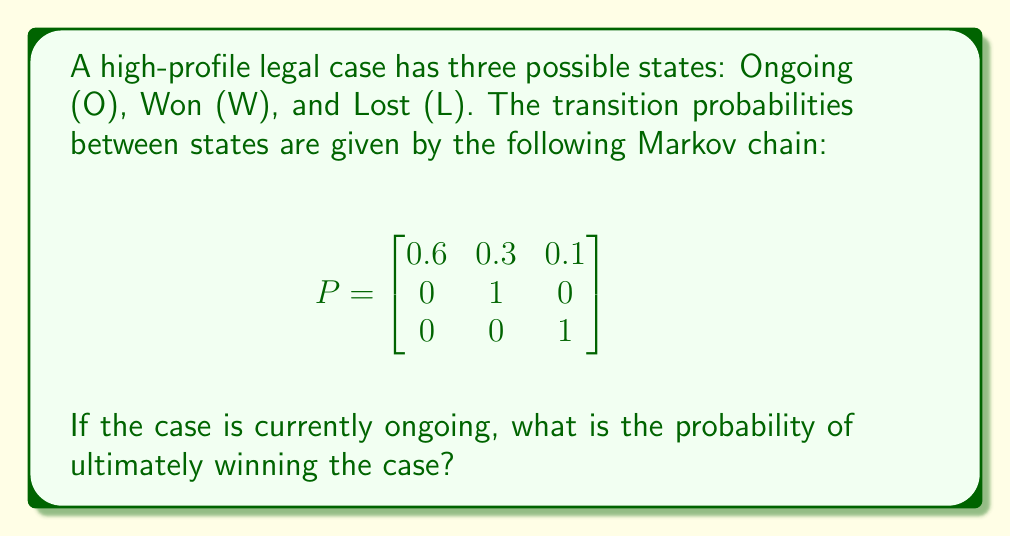Help me with this question. To solve this problem, we need to use the concept of absorbing Markov chains:

1) First, observe that W and L are absorbing states (once reached, the process stays there with probability 1).

2) We need to find the probability of reaching W before L, starting from O.

3) Let $q$ be the probability of eventually winning, starting from O. We can write:

   $q = 0.3 + 0.6q$

   This equation states that we can win immediately with probability 0.3, or stay in O with probability 0.6 and then win from there (which has probability $q$).

4) Solving this equation:

   $q = 0.3 + 0.6q$
   $0.4q = 0.3$
   $q = 0.3 / 0.4 = 0.75$

5) Therefore, the probability of ultimately winning the case, given that it's currently ongoing, is 0.75 or 75%.
Answer: 0.75 